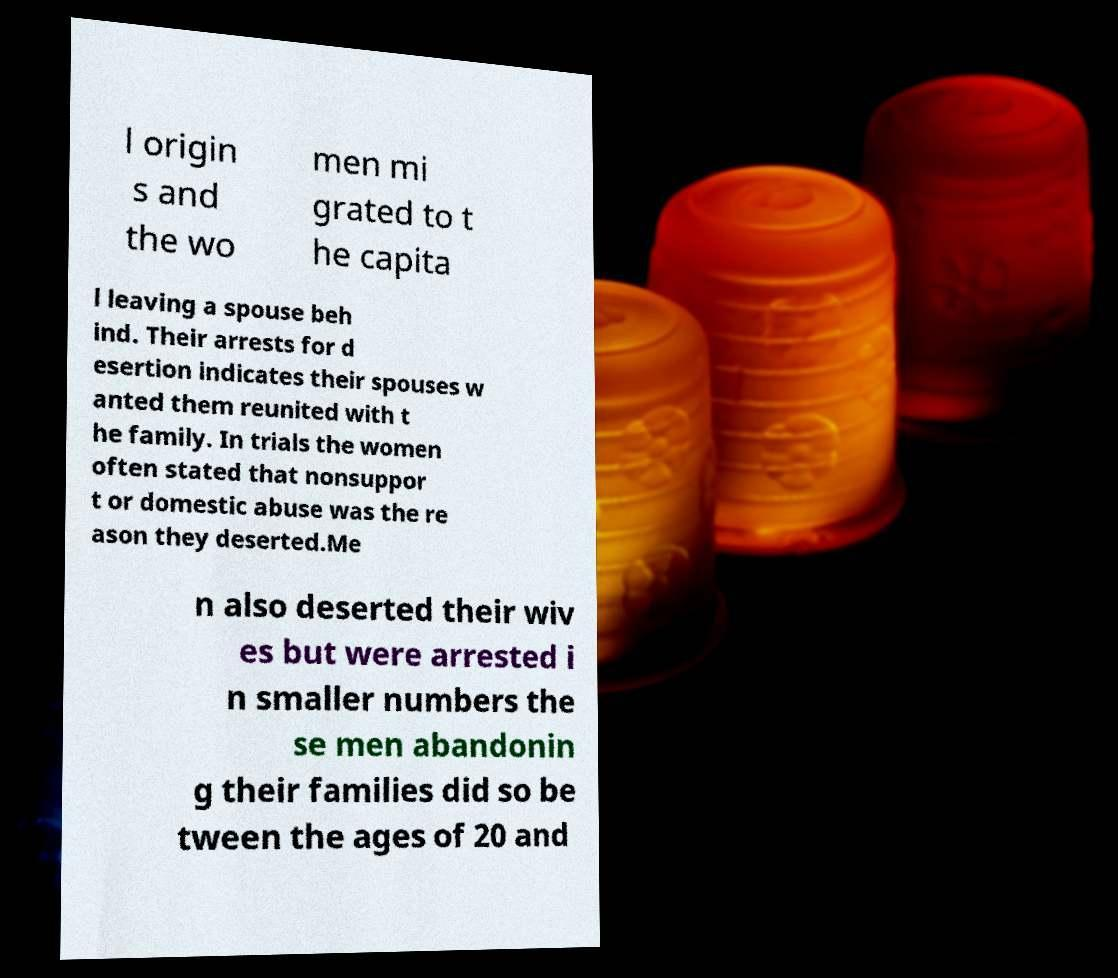Please read and relay the text visible in this image. What does it say? l origin s and the wo men mi grated to t he capita l leaving a spouse beh ind. Their arrests for d esertion indicates their spouses w anted them reunited with t he family. In trials the women often stated that nonsuppor t or domestic abuse was the re ason they deserted.Me n also deserted their wiv es but were arrested i n smaller numbers the se men abandonin g their families did so be tween the ages of 20 and 